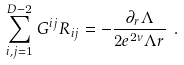Convert formula to latex. <formula><loc_0><loc_0><loc_500><loc_500>\sum _ { i , j = 1 } ^ { D - 2 } G ^ { i j } R _ { i j } = - \frac { \partial _ { r } \Lambda } { 2 e ^ { 2 \nu } \Lambda r } \ .</formula> 